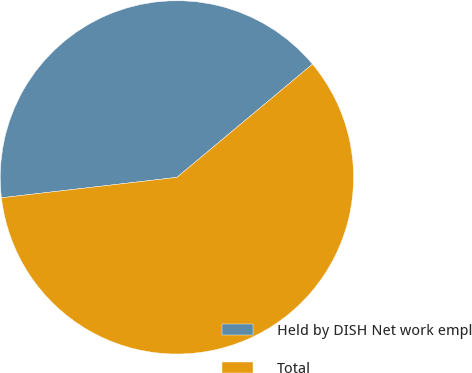Convert chart. <chart><loc_0><loc_0><loc_500><loc_500><pie_chart><fcel>Held by DISH Net work empl<fcel>Total<nl><fcel>40.77%<fcel>59.23%<nl></chart> 